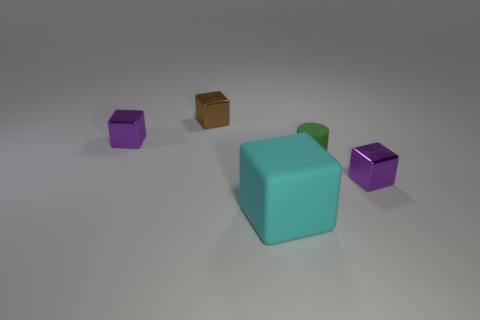Is the size of the purple block that is behind the rubber cylinder the same as the large object?
Your answer should be very brief. No. There is a small purple shiny thing that is behind the tiny green thing; are there any purple objects that are in front of it?
Offer a terse response. Yes. Are there any big cyan things made of the same material as the small green cylinder?
Keep it short and to the point. Yes. There is a tiny purple cube that is in front of the small metal object that is on the left side of the brown object; what is its material?
Your answer should be very brief. Metal. The block that is both on the left side of the green rubber cylinder and on the right side of the brown block is made of what material?
Keep it short and to the point. Rubber. Is the number of purple objects to the right of the small green thing the same as the number of small rubber objects?
Ensure brevity in your answer.  Yes. How many other shiny things are the same shape as the small brown object?
Provide a short and direct response. 2. There is a metal block that is behind the small purple metallic object behind the tiny metal thing that is right of the small brown metal thing; what size is it?
Your answer should be compact. Small. Is the small purple thing left of the large rubber cube made of the same material as the tiny brown block?
Offer a very short reply. Yes. Are there an equal number of big cyan matte blocks that are behind the tiny green rubber object and big rubber things behind the tiny brown thing?
Provide a succinct answer. Yes. 